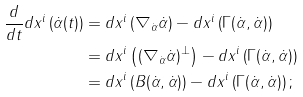Convert formula to latex. <formula><loc_0><loc_0><loc_500><loc_500>\frac { d } { d t } d x ^ { i } \left ( \dot { \alpha } ( t ) \right ) & = d x ^ { i } \left ( \nabla _ { \dot { \alpha } } \dot { \alpha } \right ) - d x ^ { i } \left ( \Gamma ( \dot { \alpha } , \dot { \alpha } ) \right ) \\ & = d x ^ { i } \left ( ( \nabla _ { \dot { \alpha } } \dot { \alpha } ) ^ { \bot } \right ) - d x ^ { i } \left ( \Gamma ( \dot { \alpha } , \dot { \alpha } ) \right ) \\ & = d x ^ { i } \left ( B ( \dot { \alpha } , \dot { \alpha } ) \right ) - d x ^ { i } \left ( \Gamma ( \dot { \alpha } , \dot { \alpha } ) \right ) ;</formula> 